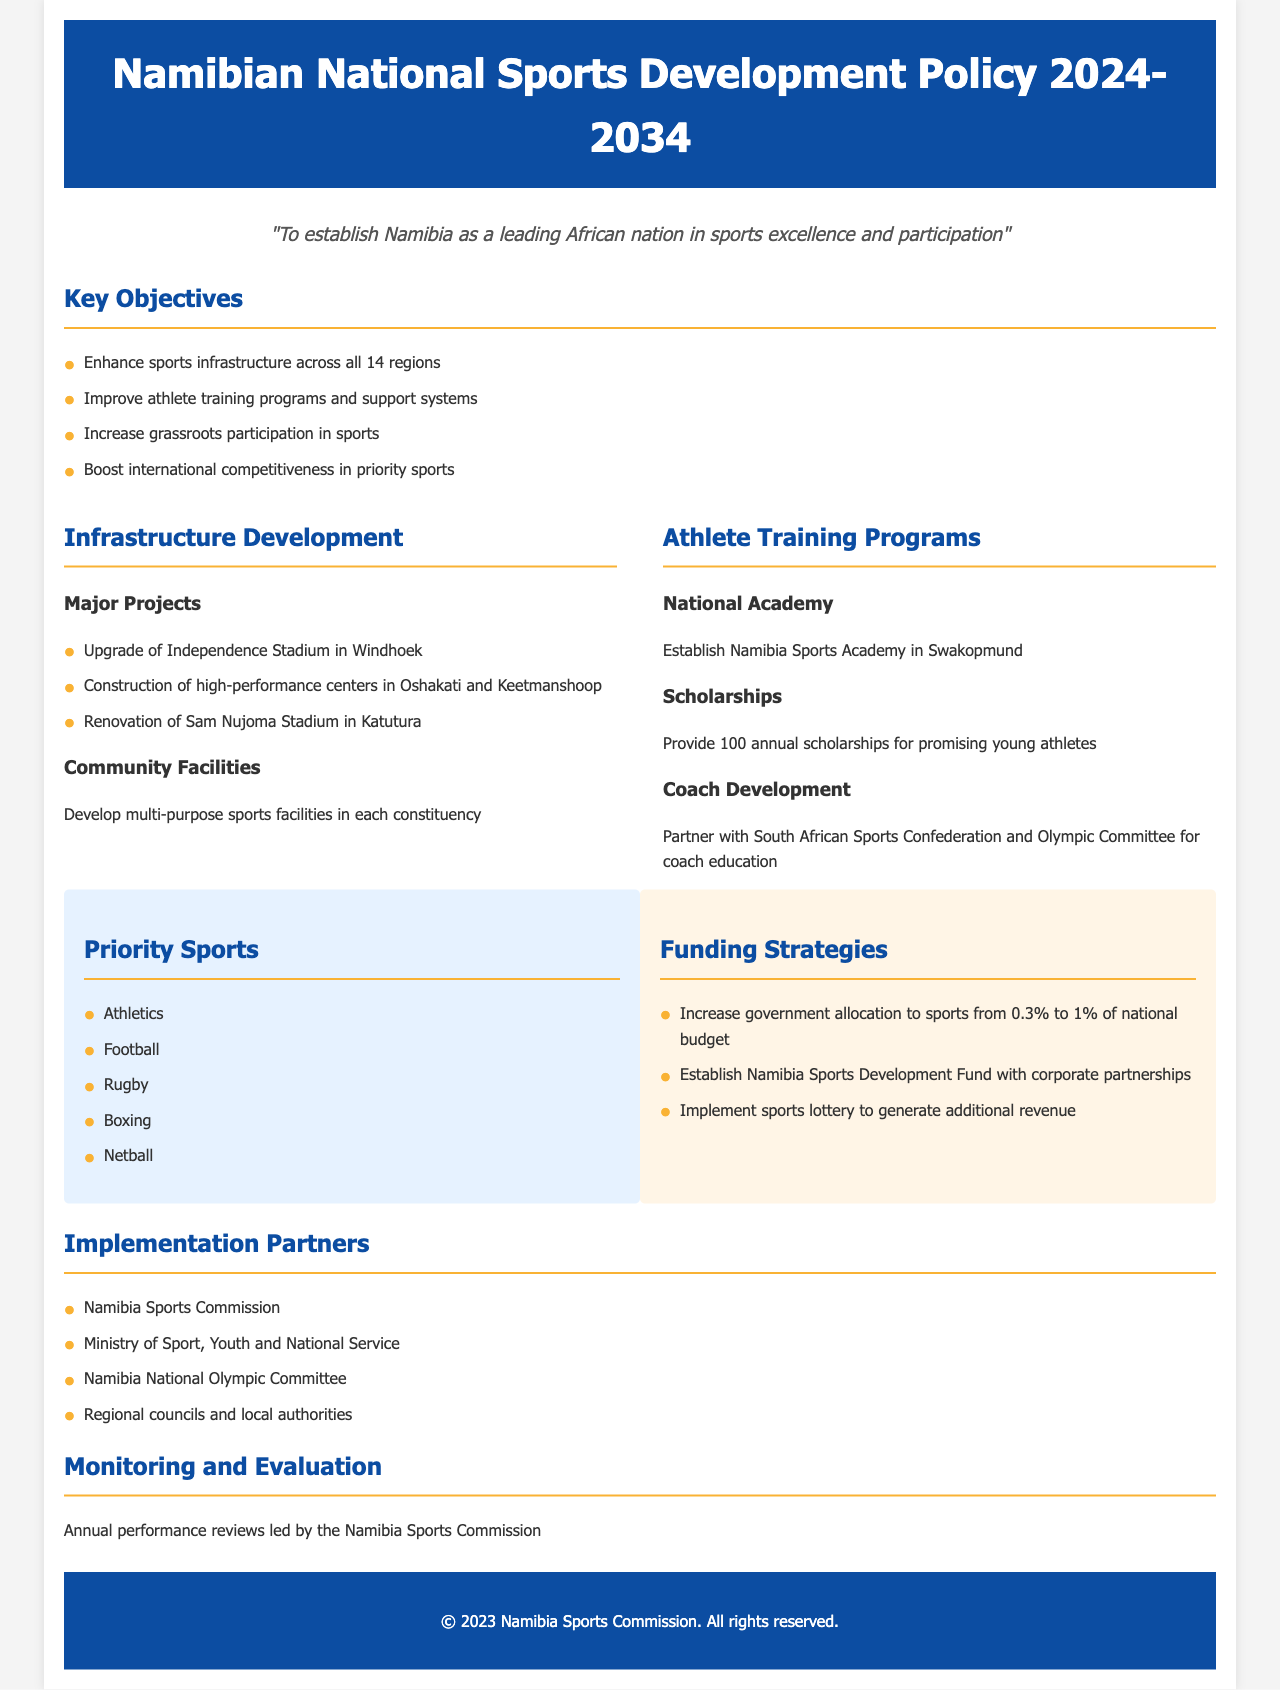What is the vision of the policy? The vision outlines the aim of the policy to establish Namibia as a leading African nation in sports excellence and participation.
Answer: To establish Namibia as a leading African nation in sports excellence and participation How many priority sports are listed in the document? The number of priority sports is directly mentioned in the section regarding priority sports.
Answer: Five What is the title of this policy document? The title is stated at the top of the document.
Answer: Namibian National Sports Development Policy 2024-2034 What percentage of the national budget will be allocated to sports? The document specifies the increase in government allocation to sports as a percentage of the national budget.
Answer: 1% Where will the Namibia Sports Academy be established? The document mentions the location of the Namibia Sports Academy within the athlete training programs section.
Answer: Swakopmund Which organization is responsible for annual performance reviews? The entity leading the annual performance reviews is identified in the monitoring and evaluation section.
Answer: Namibia Sports Commission What is one major project for infrastructure development mentioned? The document lists key infrastructure projects, and this is one example.
Answer: Upgrade of Independence Stadium in Windhoek How many scholarships will be provided annually for young athletes? The specific number of scholarships for promising young athletes is outlined in the document.
Answer: 100 